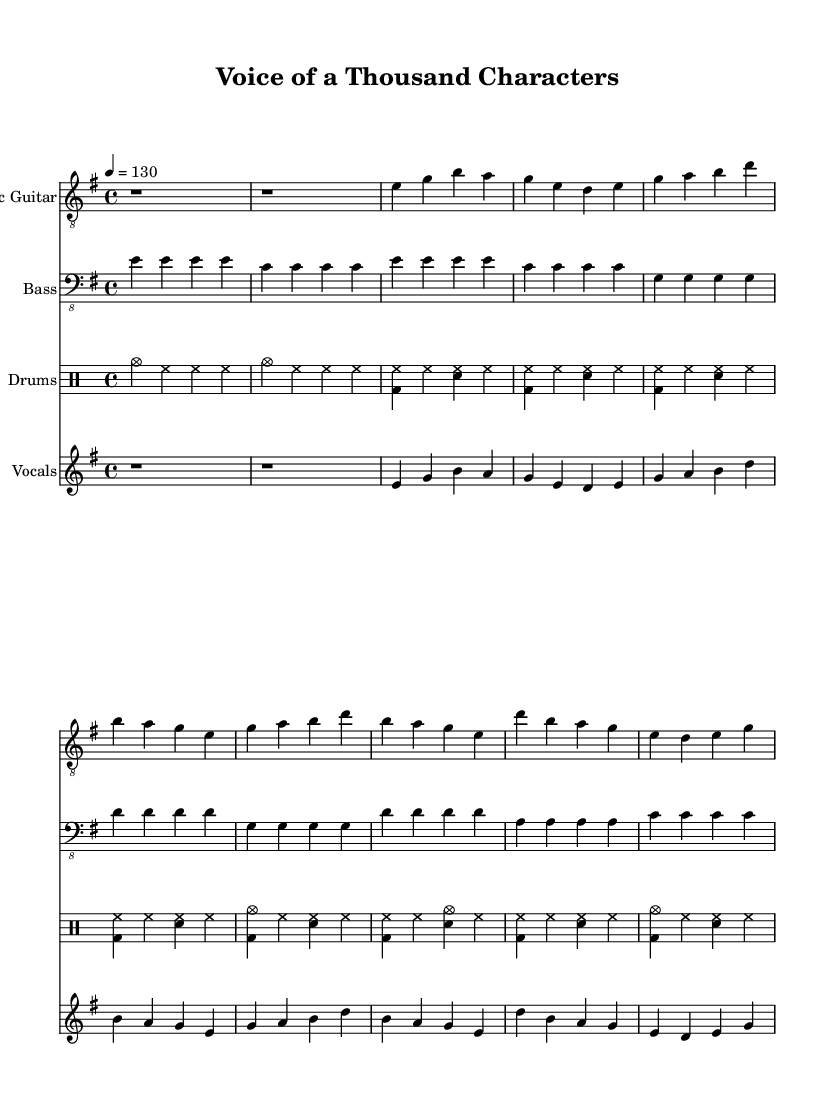What is the key signature of this music? The key signature shows two sharps, indicating that the piece is in E minor. Looking at the clef and the corresponding accidentals, we confirm the key signature.
Answer: E minor What is the time signature of the music? The time signature specified at the beginning of the score is 4/4, which can be identified by observing the notations at the start indicating that there are four beats in each measure.
Answer: 4/4 What is the indicated tempo for this piece? The tempo marking states "4 = 130," meaning that a quarter note is to be played at 130 beats per minute. This can be determined by reading the tempo indication line located after the time signature in the header section.
Answer: 130 How many measures are in the chorus section? By counting the measures specifically labeled as the chorus in the score, we find there are four measures in the chorus sections after identifying the corresponding vocal part notations.
Answer: 4 Which instruments are featured in the score? The instruments included in the score are electric guitar, bass, drums, and vocals. This can be seen by looking at the labels for each staff in the score layout indicating the respective instruments.
Answer: Electric Guitar, Bass, Drums, Vocals What are the opening words of the verse? The lyrics for the verse are "A thousand voices in my head, each one a different role," which can be identified by reading the lyric part aligned with the vocal staff and matching the text with the notational rhythm.
Answer: A thousand voices in my head 